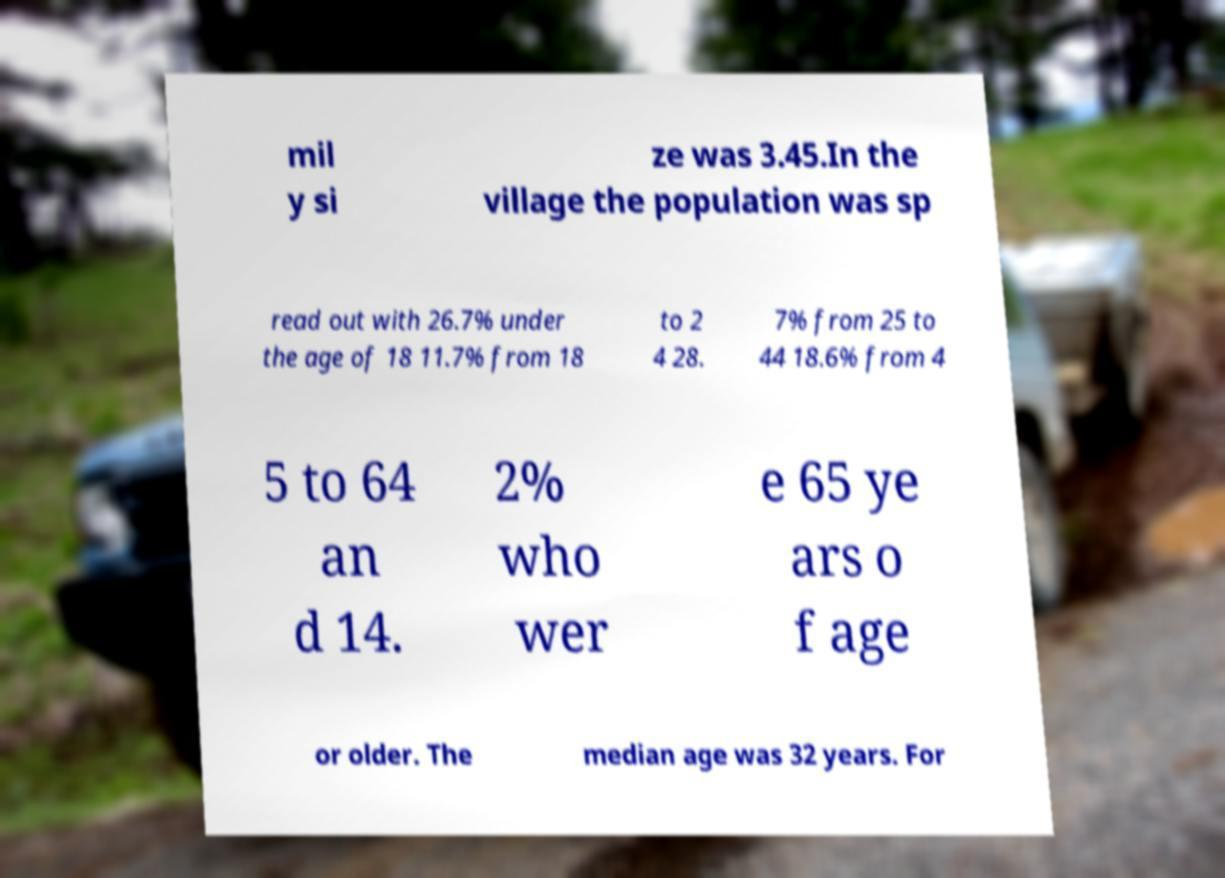What messages or text are displayed in this image? I need them in a readable, typed format. mil y si ze was 3.45.In the village the population was sp read out with 26.7% under the age of 18 11.7% from 18 to 2 4 28. 7% from 25 to 44 18.6% from 4 5 to 64 an d 14. 2% who wer e 65 ye ars o f age or older. The median age was 32 years. For 